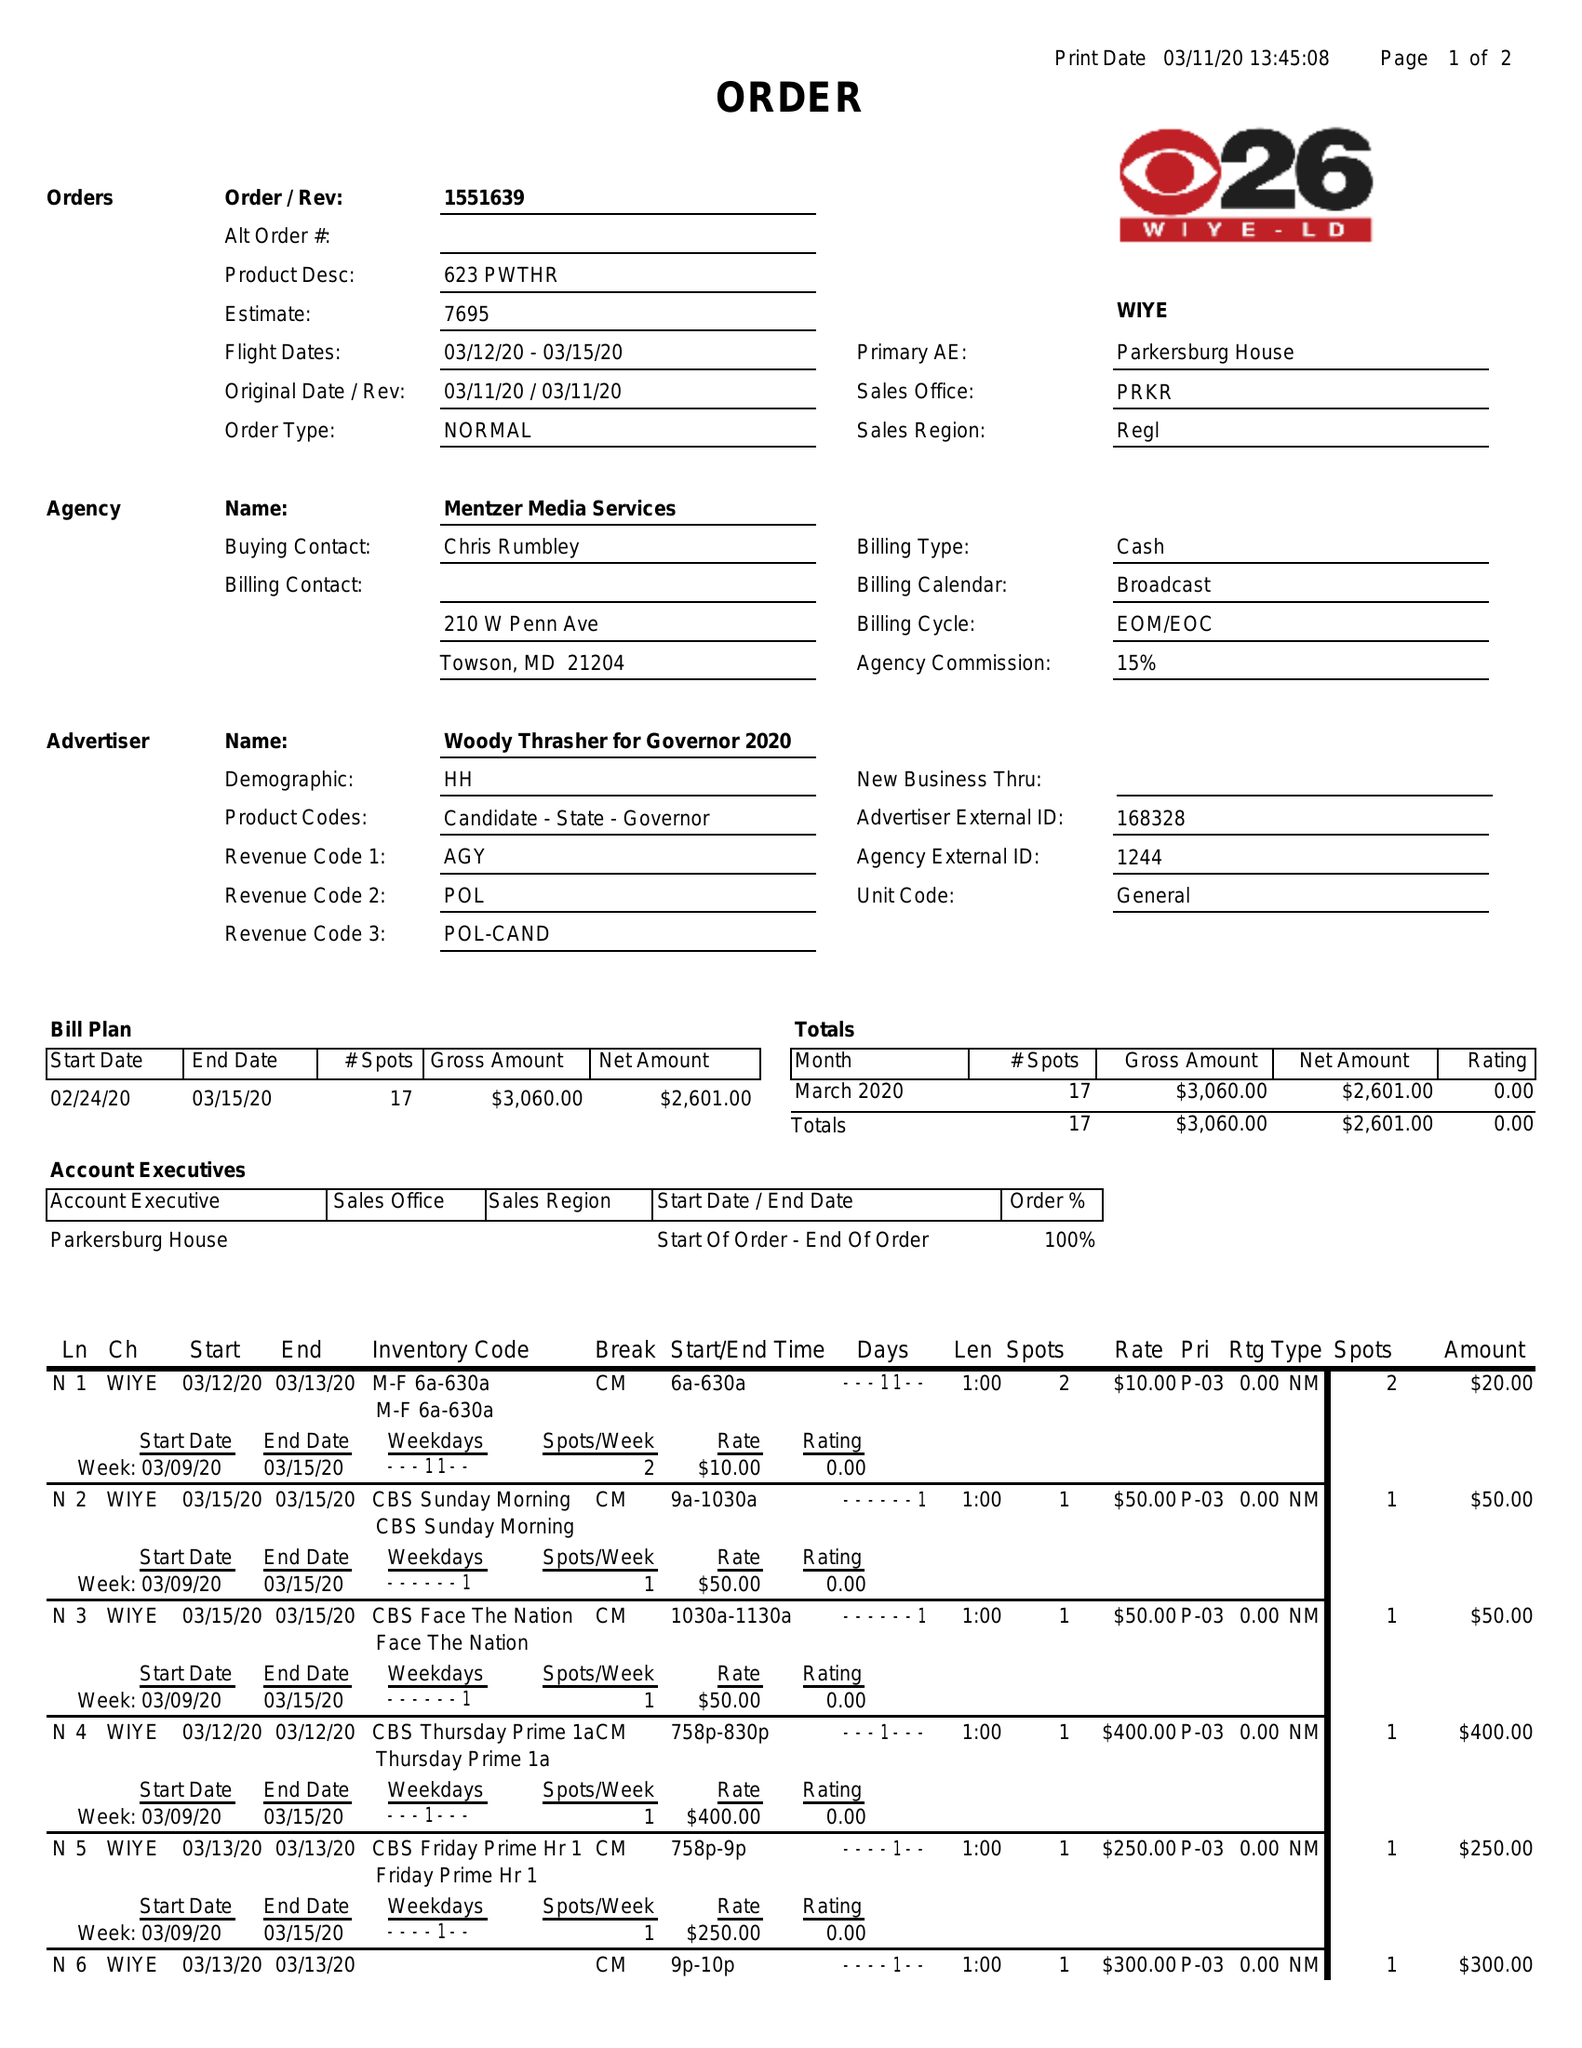What is the value for the gross_amount?
Answer the question using a single word or phrase. 3060.00 